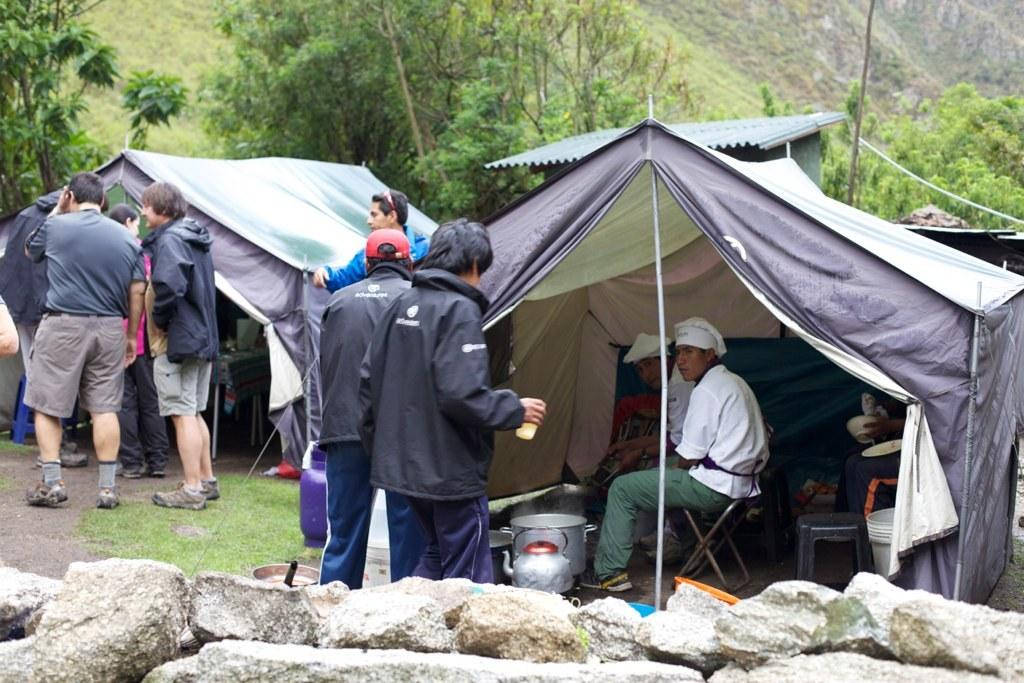What type of temporary shelters can be seen in the image? There are tent houses in the image. What are the people in the image doing? There is a group of people standing in front of a house. What type of vegetation is present in the image? There are green trees in the image. What geographical feature can be seen in the background of the image? Hills are visible in the background of the image. What is the distance between the throat and the cave in the image? There is no throat or cave present in the image. How many people are standing in front of the cave in the image? There is no cave present in the image, so it is not possible to determine how many people are standing in front of it. 